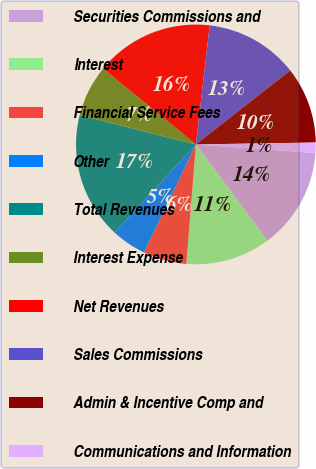Convert chart to OTSL. <chart><loc_0><loc_0><loc_500><loc_500><pie_chart><fcel>Securities Commissions and<fcel>Interest<fcel>Financial Service Fees<fcel>Other<fcel>Total Revenues<fcel>Interest Expense<fcel>Net Revenues<fcel>Sales Commissions<fcel>Admin & Incentive Comp and<fcel>Communications and Information<nl><fcel>13.69%<fcel>11.45%<fcel>5.86%<fcel>4.74%<fcel>17.05%<fcel>6.98%<fcel>15.93%<fcel>12.57%<fcel>10.34%<fcel>1.39%<nl></chart> 